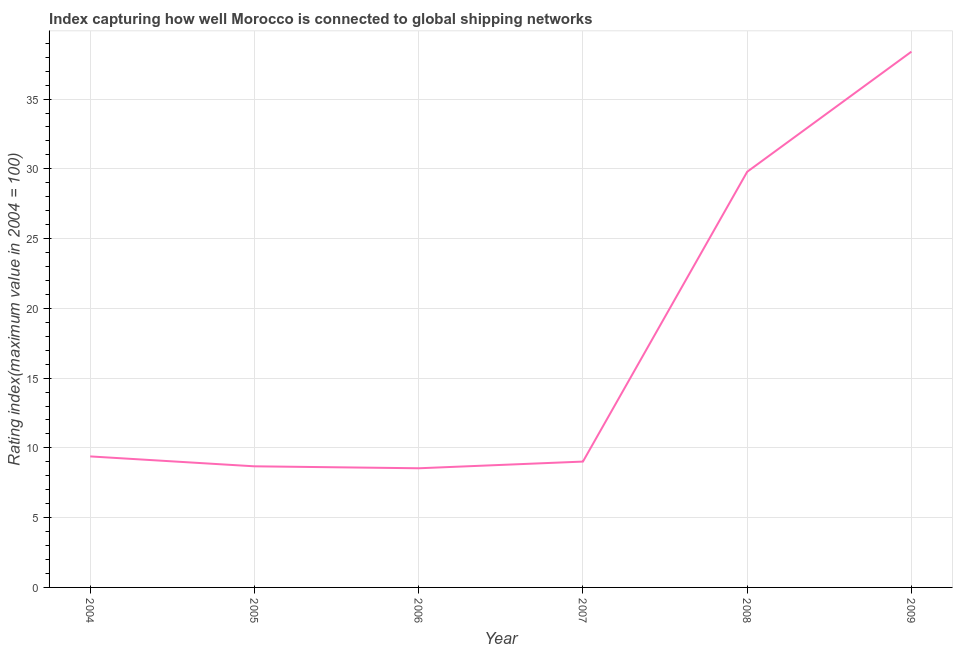What is the liner shipping connectivity index in 2009?
Offer a very short reply. 38.4. Across all years, what is the maximum liner shipping connectivity index?
Give a very brief answer. 38.4. Across all years, what is the minimum liner shipping connectivity index?
Provide a short and direct response. 8.54. In which year was the liner shipping connectivity index maximum?
Offer a terse response. 2009. What is the sum of the liner shipping connectivity index?
Provide a succinct answer. 103.82. What is the difference between the liner shipping connectivity index in 2006 and 2008?
Your answer should be compact. -21.25. What is the average liner shipping connectivity index per year?
Provide a short and direct response. 17.3. What is the median liner shipping connectivity index?
Give a very brief answer. 9.21. In how many years, is the liner shipping connectivity index greater than 11 ?
Your answer should be very brief. 2. Do a majority of the years between 2009 and 2006 (inclusive) have liner shipping connectivity index greater than 14 ?
Your response must be concise. Yes. What is the ratio of the liner shipping connectivity index in 2006 to that in 2008?
Provide a succinct answer. 0.29. Is the liner shipping connectivity index in 2005 less than that in 2008?
Ensure brevity in your answer.  Yes. What is the difference between the highest and the second highest liner shipping connectivity index?
Ensure brevity in your answer.  8.61. Is the sum of the liner shipping connectivity index in 2005 and 2008 greater than the maximum liner shipping connectivity index across all years?
Provide a short and direct response. Yes. What is the difference between the highest and the lowest liner shipping connectivity index?
Your answer should be compact. 29.86. How many years are there in the graph?
Provide a short and direct response. 6. What is the difference between two consecutive major ticks on the Y-axis?
Offer a terse response. 5. Are the values on the major ticks of Y-axis written in scientific E-notation?
Offer a very short reply. No. Does the graph contain any zero values?
Your answer should be very brief. No. What is the title of the graph?
Make the answer very short. Index capturing how well Morocco is connected to global shipping networks. What is the label or title of the Y-axis?
Your response must be concise. Rating index(maximum value in 2004 = 100). What is the Rating index(maximum value in 2004 = 100) of 2004?
Your answer should be very brief. 9.39. What is the Rating index(maximum value in 2004 = 100) of 2005?
Provide a succinct answer. 8.68. What is the Rating index(maximum value in 2004 = 100) of 2006?
Keep it short and to the point. 8.54. What is the Rating index(maximum value in 2004 = 100) of 2007?
Ensure brevity in your answer.  9.02. What is the Rating index(maximum value in 2004 = 100) in 2008?
Keep it short and to the point. 29.79. What is the Rating index(maximum value in 2004 = 100) in 2009?
Give a very brief answer. 38.4. What is the difference between the Rating index(maximum value in 2004 = 100) in 2004 and 2005?
Give a very brief answer. 0.71. What is the difference between the Rating index(maximum value in 2004 = 100) in 2004 and 2006?
Provide a succinct answer. 0.85. What is the difference between the Rating index(maximum value in 2004 = 100) in 2004 and 2007?
Ensure brevity in your answer.  0.37. What is the difference between the Rating index(maximum value in 2004 = 100) in 2004 and 2008?
Keep it short and to the point. -20.4. What is the difference between the Rating index(maximum value in 2004 = 100) in 2004 and 2009?
Your answer should be very brief. -29.01. What is the difference between the Rating index(maximum value in 2004 = 100) in 2005 and 2006?
Offer a terse response. 0.14. What is the difference between the Rating index(maximum value in 2004 = 100) in 2005 and 2007?
Ensure brevity in your answer.  -0.34. What is the difference between the Rating index(maximum value in 2004 = 100) in 2005 and 2008?
Your answer should be very brief. -21.11. What is the difference between the Rating index(maximum value in 2004 = 100) in 2005 and 2009?
Give a very brief answer. -29.72. What is the difference between the Rating index(maximum value in 2004 = 100) in 2006 and 2007?
Make the answer very short. -0.48. What is the difference between the Rating index(maximum value in 2004 = 100) in 2006 and 2008?
Offer a very short reply. -21.25. What is the difference between the Rating index(maximum value in 2004 = 100) in 2006 and 2009?
Provide a succinct answer. -29.86. What is the difference between the Rating index(maximum value in 2004 = 100) in 2007 and 2008?
Give a very brief answer. -20.77. What is the difference between the Rating index(maximum value in 2004 = 100) in 2007 and 2009?
Give a very brief answer. -29.38. What is the difference between the Rating index(maximum value in 2004 = 100) in 2008 and 2009?
Keep it short and to the point. -8.61. What is the ratio of the Rating index(maximum value in 2004 = 100) in 2004 to that in 2005?
Offer a very short reply. 1.08. What is the ratio of the Rating index(maximum value in 2004 = 100) in 2004 to that in 2006?
Provide a short and direct response. 1.1. What is the ratio of the Rating index(maximum value in 2004 = 100) in 2004 to that in 2007?
Provide a succinct answer. 1.04. What is the ratio of the Rating index(maximum value in 2004 = 100) in 2004 to that in 2008?
Provide a succinct answer. 0.32. What is the ratio of the Rating index(maximum value in 2004 = 100) in 2004 to that in 2009?
Ensure brevity in your answer.  0.24. What is the ratio of the Rating index(maximum value in 2004 = 100) in 2005 to that in 2006?
Give a very brief answer. 1.02. What is the ratio of the Rating index(maximum value in 2004 = 100) in 2005 to that in 2007?
Keep it short and to the point. 0.96. What is the ratio of the Rating index(maximum value in 2004 = 100) in 2005 to that in 2008?
Ensure brevity in your answer.  0.29. What is the ratio of the Rating index(maximum value in 2004 = 100) in 2005 to that in 2009?
Make the answer very short. 0.23. What is the ratio of the Rating index(maximum value in 2004 = 100) in 2006 to that in 2007?
Make the answer very short. 0.95. What is the ratio of the Rating index(maximum value in 2004 = 100) in 2006 to that in 2008?
Offer a terse response. 0.29. What is the ratio of the Rating index(maximum value in 2004 = 100) in 2006 to that in 2009?
Make the answer very short. 0.22. What is the ratio of the Rating index(maximum value in 2004 = 100) in 2007 to that in 2008?
Offer a terse response. 0.3. What is the ratio of the Rating index(maximum value in 2004 = 100) in 2007 to that in 2009?
Offer a very short reply. 0.23. What is the ratio of the Rating index(maximum value in 2004 = 100) in 2008 to that in 2009?
Offer a very short reply. 0.78. 